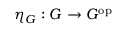Convert formula to latex. <formula><loc_0><loc_0><loc_500><loc_500>\eta _ { G } \colon G \to G ^ { o p }</formula> 